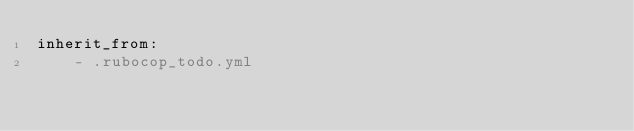<code> <loc_0><loc_0><loc_500><loc_500><_YAML_>inherit_from:
    - .rubocop_todo.yml</code> 